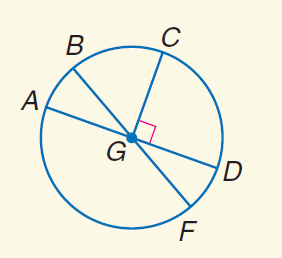Answer the mathemtical geometry problem and directly provide the correct option letter.
Question: In \odot G, m \angle A G B = 30 and C G \perp G D. Find m \widehat A B.
Choices: A: 30 B: 60 C: 90 D: 155 A 